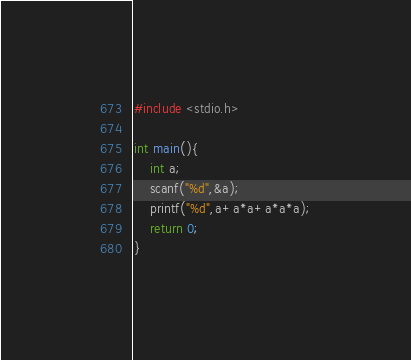<code> <loc_0><loc_0><loc_500><loc_500><_C_>#include <stdio.h>

int main(){
    int a;
    scanf("%d",&a);
    printf("%d",a+a*a+a*a*a);
    return 0;
}</code> 